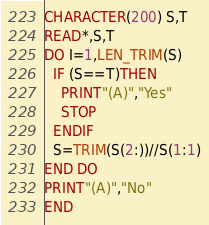Convert code to text. <code><loc_0><loc_0><loc_500><loc_500><_FORTRAN_>CHARACTER(200) S,T
READ*,S,T
DO I=1,LEN_TRIM(S)
  IF (S==T)THEN
    PRINT"(A)","Yes"
    STOP
  ENDIF
  S=TRIM(S(2:))//S(1:1)
END DO
PRINT"(A)","No"
END </code> 